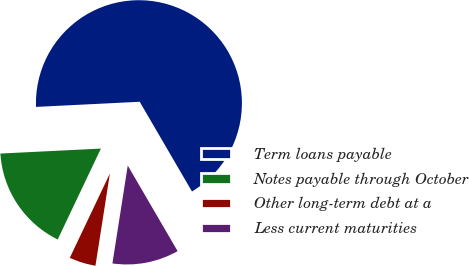Convert chart to OTSL. <chart><loc_0><loc_0><loc_500><loc_500><pie_chart><fcel>Term loans payable<fcel>Notes payable through October<fcel>Other long-term debt at a<fcel>Less current maturities<nl><fcel>67.39%<fcel>17.15%<fcel>4.59%<fcel>10.87%<nl></chart> 